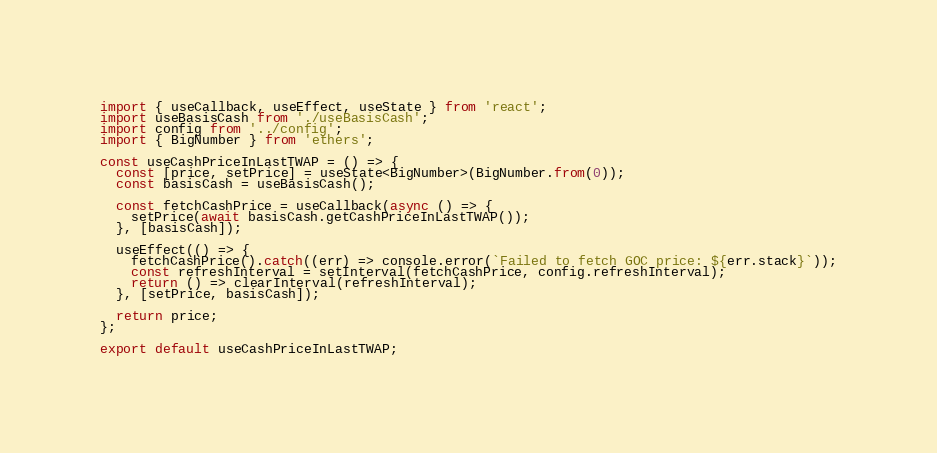<code> <loc_0><loc_0><loc_500><loc_500><_TypeScript_>import { useCallback, useEffect, useState } from 'react';
import useBasisCash from './useBasisCash';
import config from '../config';
import { BigNumber } from 'ethers';

const useCashPriceInLastTWAP = () => {
  const [price, setPrice] = useState<BigNumber>(BigNumber.from(0));
  const basisCash = useBasisCash();

  const fetchCashPrice = useCallback(async () => {
    setPrice(await basisCash.getCashPriceInLastTWAP());
  }, [basisCash]);

  useEffect(() => {
    fetchCashPrice().catch((err) => console.error(`Failed to fetch GOC price: ${err.stack}`));
    const refreshInterval = setInterval(fetchCashPrice, config.refreshInterval);
    return () => clearInterval(refreshInterval);
  }, [setPrice, basisCash]);

  return price;
};

export default useCashPriceInLastTWAP;
</code> 